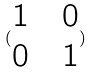<formula> <loc_0><loc_0><loc_500><loc_500>( \begin{matrix} 1 & & 0 \\ 0 & & 1 \end{matrix} )</formula> 